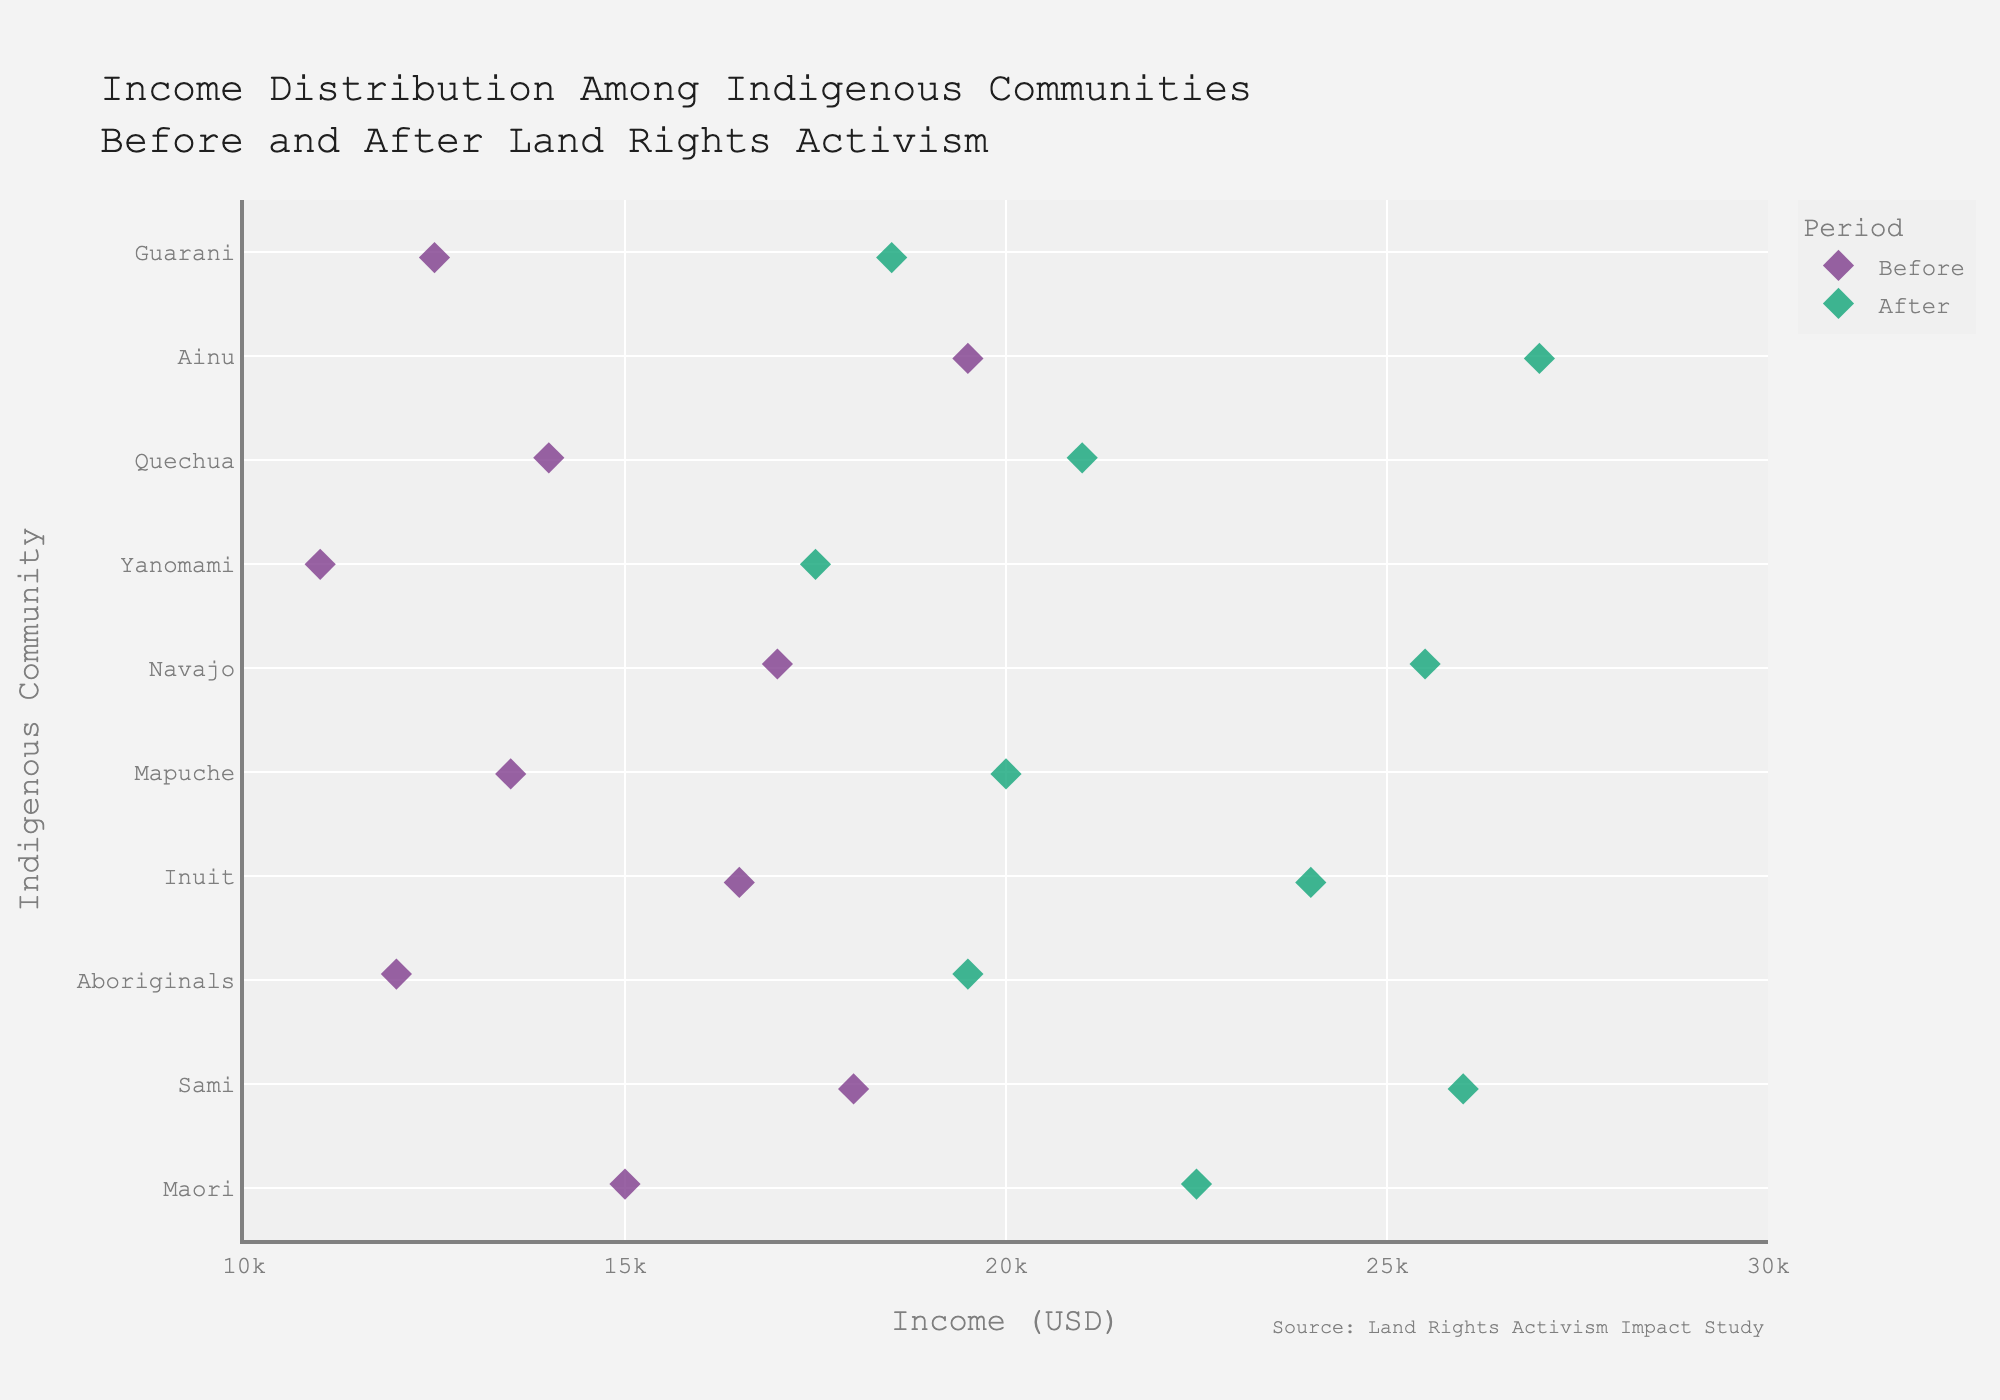What's the title of the figure? The title is usually displayed at the top of the figure. In this case, it reads: "Income Distribution Among Indigenous Communities Before and After Land Rights Activism".
Answer: Income Distribution Among Indigenous Communities Before and After Land Rights Activism Which community has the highest income after land rights activism? To find the highest income after activism, look at the 'After' data points and compare them across all communities. The 'Ainu' community has the highest income after activism at $27,000.
Answer: Ainu What is the difference in income for the Maori community before and after land rights activism? Locate the income values for the Maori community in both 'Before' and 'After' periods. Subtract the 'Before' income ($15,000) from the 'After' income ($22,500).
Answer: 7,500 USD Which community experienced the smallest increase in income due to land rights activism? Calculate the income difference for each community. The 'Yanomami' community increased from $11,000 to $17,500, showing an increase of $6,500 - the smallest among all communities.
Answer: Yanomami Compare the income change for the Navajo and Guarani communities. Which community had a greater absolute increase? Calculate the income increase for both communities. Navajo increased from $17,000 to $25,500 (an increase of $8,500), and Guarani increased from $12,500 to $18,500 (an increase of $6,000). The Navajo community had a greater increase.
Answer: Navajo What is the average income before land rights activism among all communities? Sum up the 'Before' income for all communities and divide by the number of communities. The total 'Before' income is ($15,000 + $18,000 + $12,000 + $16,500 + $13,500 + $17,000 + $11,000 + $14,000 + $19,500 + $12,500) = $149,000. Divide by the number of communities (10).
Answer: 14,900 USD What is the average income after land rights activism among all communities? Sum up the 'After' income for all communities and divide by the number of communities. The total 'After' income is ($22,500 + $26,000 + $19,500 + $24,000 + $20,000 + $25,500 + $17,500 + $21,000 + $27,000 + $18,500) = $221,500. Divide by the number of communities (10).
Answer: 22,150 USD How did the income distribution shift compare 'Before' and 'After' activism in terms of spread and central tendency? Observe the spread (range) and central tendency (average) for both periods. The 'Before' income ranges from $11,000 to $19,500, while the 'After' income ranges from $17,500 to $27,000. Central tendencies (average incomes) shifted from $14,900 'Before' to $22,150 'After'. This indicates a general increase in income and a shift towards higher income levels.
Answer: Increased spread and average Which community shows the most improvement in relative terms, considering the percentage increase in income before and after activism? Calculate the percentage increase for each community: ((Income After - Income Before) / Income Before) * 100. The percentage increase for the 'Ainu' community is ((27,000 - 19,500) / 19,500) * 100 = 38.46%. Compare this to all other communities to find that Ainu exhibits the most improvement relatively.
Answer: Ainu 